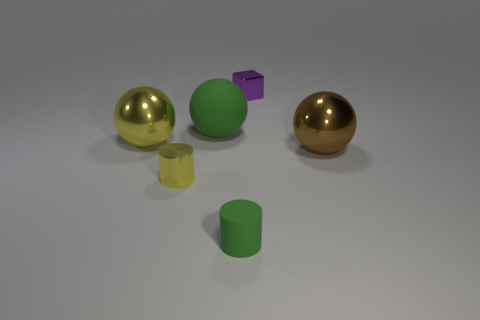Subtract all yellow balls. How many balls are left? 2 Subtract all yellow balls. How many balls are left? 2 Subtract all cylinders. How many objects are left? 4 Subtract all blue cylinders. Subtract all red spheres. How many cylinders are left? 2 Subtract all red blocks. How many green cylinders are left? 1 Subtract all yellow metal cylinders. Subtract all big blue matte blocks. How many objects are left? 5 Add 5 large brown metallic things. How many large brown metallic things are left? 6 Add 4 big yellow matte spheres. How many big yellow matte spheres exist? 4 Add 4 red rubber spheres. How many objects exist? 10 Subtract 0 red balls. How many objects are left? 6 